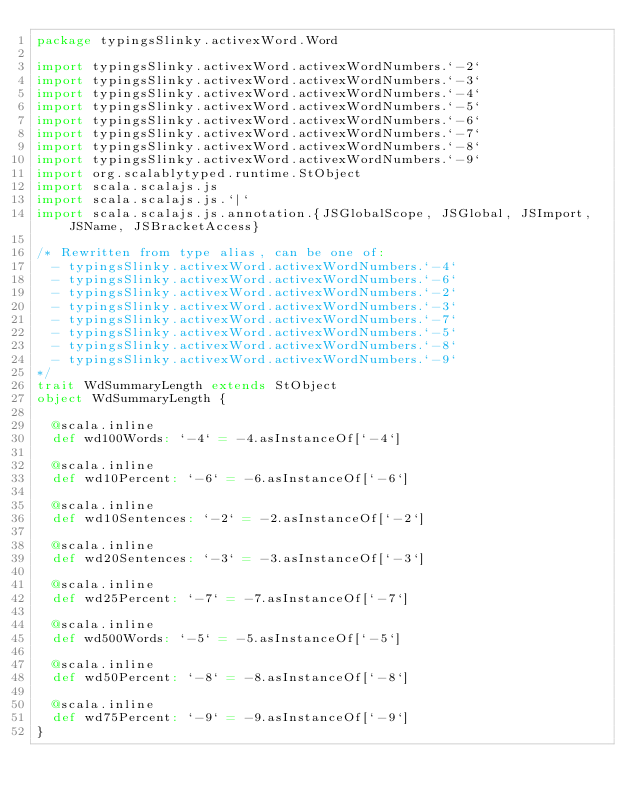Convert code to text. <code><loc_0><loc_0><loc_500><loc_500><_Scala_>package typingsSlinky.activexWord.Word

import typingsSlinky.activexWord.activexWordNumbers.`-2`
import typingsSlinky.activexWord.activexWordNumbers.`-3`
import typingsSlinky.activexWord.activexWordNumbers.`-4`
import typingsSlinky.activexWord.activexWordNumbers.`-5`
import typingsSlinky.activexWord.activexWordNumbers.`-6`
import typingsSlinky.activexWord.activexWordNumbers.`-7`
import typingsSlinky.activexWord.activexWordNumbers.`-8`
import typingsSlinky.activexWord.activexWordNumbers.`-9`
import org.scalablytyped.runtime.StObject
import scala.scalajs.js
import scala.scalajs.js.`|`
import scala.scalajs.js.annotation.{JSGlobalScope, JSGlobal, JSImport, JSName, JSBracketAccess}

/* Rewritten from type alias, can be one of: 
  - typingsSlinky.activexWord.activexWordNumbers.`-4`
  - typingsSlinky.activexWord.activexWordNumbers.`-6`
  - typingsSlinky.activexWord.activexWordNumbers.`-2`
  - typingsSlinky.activexWord.activexWordNumbers.`-3`
  - typingsSlinky.activexWord.activexWordNumbers.`-7`
  - typingsSlinky.activexWord.activexWordNumbers.`-5`
  - typingsSlinky.activexWord.activexWordNumbers.`-8`
  - typingsSlinky.activexWord.activexWordNumbers.`-9`
*/
trait WdSummaryLength extends StObject
object WdSummaryLength {
  
  @scala.inline
  def wd100Words: `-4` = -4.asInstanceOf[`-4`]
  
  @scala.inline
  def wd10Percent: `-6` = -6.asInstanceOf[`-6`]
  
  @scala.inline
  def wd10Sentences: `-2` = -2.asInstanceOf[`-2`]
  
  @scala.inline
  def wd20Sentences: `-3` = -3.asInstanceOf[`-3`]
  
  @scala.inline
  def wd25Percent: `-7` = -7.asInstanceOf[`-7`]
  
  @scala.inline
  def wd500Words: `-5` = -5.asInstanceOf[`-5`]
  
  @scala.inline
  def wd50Percent: `-8` = -8.asInstanceOf[`-8`]
  
  @scala.inline
  def wd75Percent: `-9` = -9.asInstanceOf[`-9`]
}
</code> 